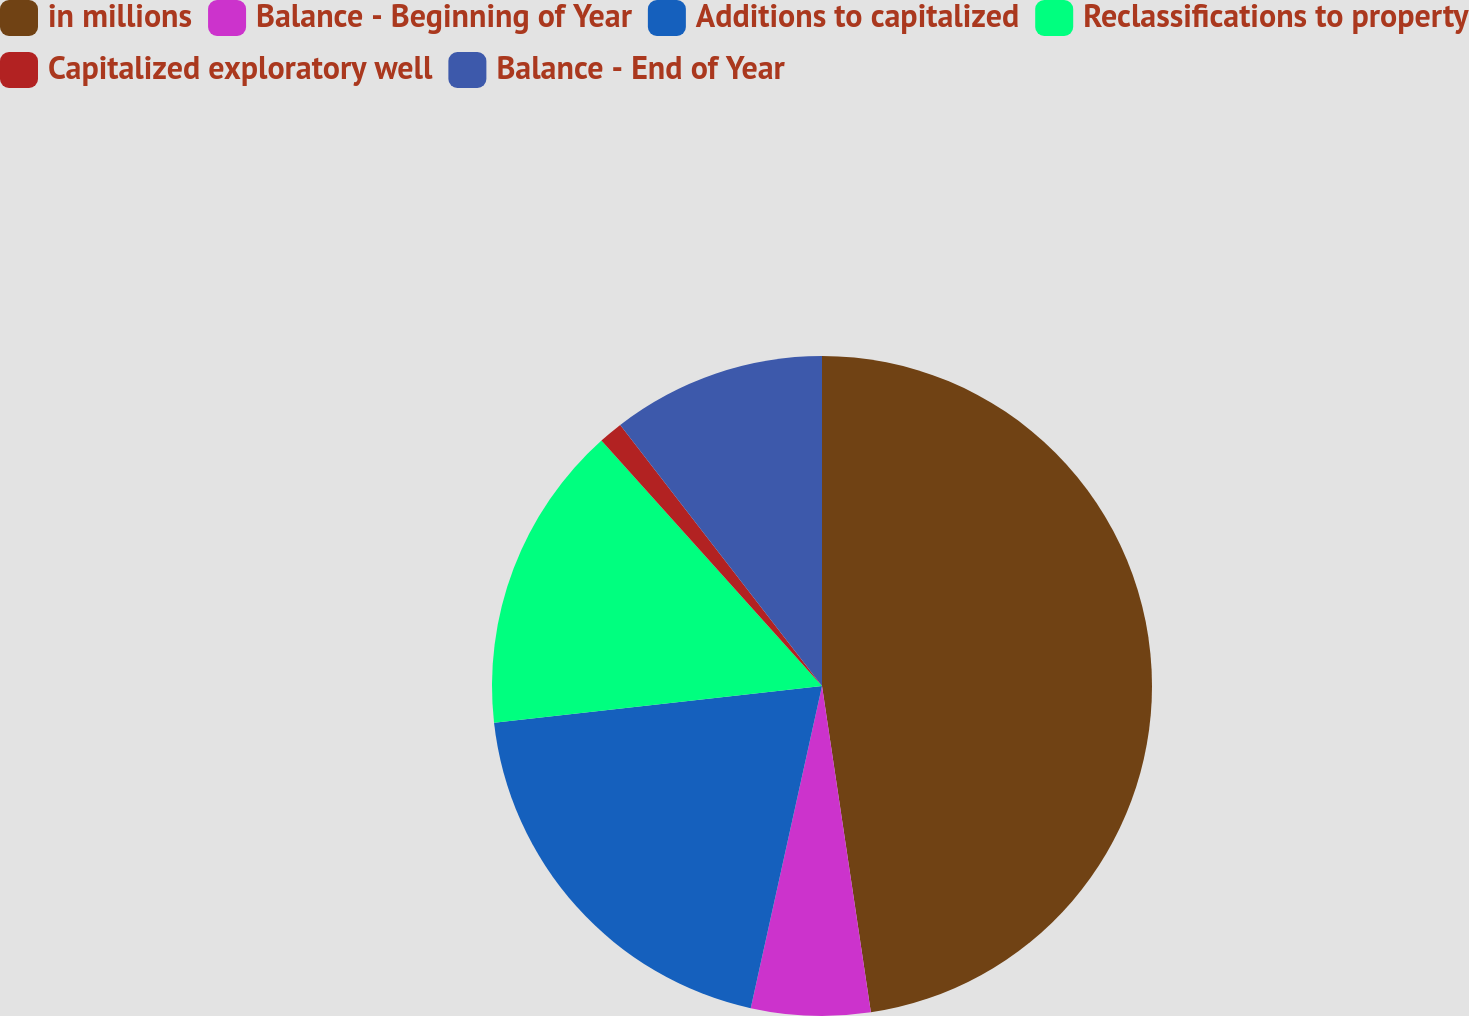<chart> <loc_0><loc_0><loc_500><loc_500><pie_chart><fcel>in millions<fcel>Balance - Beginning of Year<fcel>Additions to capitalized<fcel>Reclassifications to property<fcel>Capitalized exploratory well<fcel>Balance - End of Year<nl><fcel>47.63%<fcel>5.83%<fcel>19.76%<fcel>15.12%<fcel>1.18%<fcel>10.47%<nl></chart> 